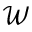Convert formula to latex. <formula><loc_0><loc_0><loc_500><loc_500>\mathcal { W }</formula> 